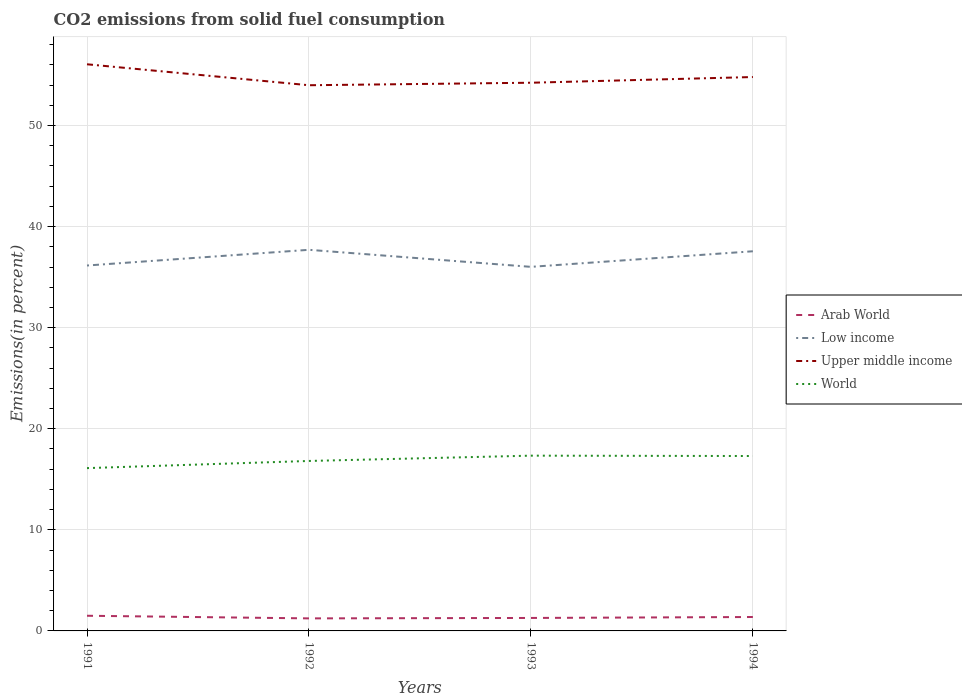Is the number of lines equal to the number of legend labels?
Offer a very short reply. Yes. Across all years, what is the maximum total CO2 emitted in Upper middle income?
Ensure brevity in your answer.  53.99. What is the total total CO2 emitted in Low income in the graph?
Your response must be concise. -1.55. What is the difference between the highest and the second highest total CO2 emitted in Upper middle income?
Your response must be concise. 2.07. What is the difference between two consecutive major ticks on the Y-axis?
Offer a very short reply. 10. Does the graph contain any zero values?
Your answer should be compact. No. Does the graph contain grids?
Make the answer very short. Yes. How many legend labels are there?
Ensure brevity in your answer.  4. How are the legend labels stacked?
Keep it short and to the point. Vertical. What is the title of the graph?
Keep it short and to the point. CO2 emissions from solid fuel consumption. What is the label or title of the X-axis?
Give a very brief answer. Years. What is the label or title of the Y-axis?
Provide a short and direct response. Emissions(in percent). What is the Emissions(in percent) of Arab World in 1991?
Your response must be concise. 1.5. What is the Emissions(in percent) in Low income in 1991?
Offer a terse response. 36.15. What is the Emissions(in percent) in Upper middle income in 1991?
Ensure brevity in your answer.  56.06. What is the Emissions(in percent) in World in 1991?
Your answer should be compact. 16.11. What is the Emissions(in percent) of Arab World in 1992?
Provide a succinct answer. 1.24. What is the Emissions(in percent) in Low income in 1992?
Your answer should be compact. 37.7. What is the Emissions(in percent) of Upper middle income in 1992?
Offer a terse response. 53.99. What is the Emissions(in percent) of World in 1992?
Your response must be concise. 16.81. What is the Emissions(in percent) in Arab World in 1993?
Ensure brevity in your answer.  1.28. What is the Emissions(in percent) in Low income in 1993?
Your answer should be very brief. 36.02. What is the Emissions(in percent) of Upper middle income in 1993?
Provide a succinct answer. 54.23. What is the Emissions(in percent) in World in 1993?
Ensure brevity in your answer.  17.34. What is the Emissions(in percent) in Arab World in 1994?
Ensure brevity in your answer.  1.38. What is the Emissions(in percent) of Low income in 1994?
Make the answer very short. 37.56. What is the Emissions(in percent) in Upper middle income in 1994?
Your response must be concise. 54.8. What is the Emissions(in percent) of World in 1994?
Your answer should be compact. 17.3. Across all years, what is the maximum Emissions(in percent) of Arab World?
Ensure brevity in your answer.  1.5. Across all years, what is the maximum Emissions(in percent) in Low income?
Offer a terse response. 37.7. Across all years, what is the maximum Emissions(in percent) of Upper middle income?
Your answer should be compact. 56.06. Across all years, what is the maximum Emissions(in percent) of World?
Keep it short and to the point. 17.34. Across all years, what is the minimum Emissions(in percent) of Arab World?
Your answer should be compact. 1.24. Across all years, what is the minimum Emissions(in percent) of Low income?
Ensure brevity in your answer.  36.02. Across all years, what is the minimum Emissions(in percent) in Upper middle income?
Ensure brevity in your answer.  53.99. Across all years, what is the minimum Emissions(in percent) in World?
Keep it short and to the point. 16.11. What is the total Emissions(in percent) of Arab World in the graph?
Your answer should be compact. 5.4. What is the total Emissions(in percent) in Low income in the graph?
Offer a very short reply. 147.43. What is the total Emissions(in percent) of Upper middle income in the graph?
Give a very brief answer. 219.07. What is the total Emissions(in percent) in World in the graph?
Your answer should be very brief. 67.56. What is the difference between the Emissions(in percent) in Arab World in 1991 and that in 1992?
Offer a terse response. 0.26. What is the difference between the Emissions(in percent) of Low income in 1991 and that in 1992?
Provide a succinct answer. -1.55. What is the difference between the Emissions(in percent) in Upper middle income in 1991 and that in 1992?
Make the answer very short. 2.07. What is the difference between the Emissions(in percent) of World in 1991 and that in 1992?
Offer a very short reply. -0.71. What is the difference between the Emissions(in percent) of Arab World in 1991 and that in 1993?
Keep it short and to the point. 0.22. What is the difference between the Emissions(in percent) of Low income in 1991 and that in 1993?
Make the answer very short. 0.13. What is the difference between the Emissions(in percent) of Upper middle income in 1991 and that in 1993?
Your answer should be compact. 1.83. What is the difference between the Emissions(in percent) in World in 1991 and that in 1993?
Offer a terse response. -1.23. What is the difference between the Emissions(in percent) in Arab World in 1991 and that in 1994?
Provide a succinct answer. 0.12. What is the difference between the Emissions(in percent) in Low income in 1991 and that in 1994?
Offer a terse response. -1.41. What is the difference between the Emissions(in percent) of Upper middle income in 1991 and that in 1994?
Offer a terse response. 1.26. What is the difference between the Emissions(in percent) in World in 1991 and that in 1994?
Provide a short and direct response. -1.2. What is the difference between the Emissions(in percent) in Arab World in 1992 and that in 1993?
Provide a short and direct response. -0.04. What is the difference between the Emissions(in percent) of Low income in 1992 and that in 1993?
Provide a succinct answer. 1.69. What is the difference between the Emissions(in percent) of Upper middle income in 1992 and that in 1993?
Provide a short and direct response. -0.25. What is the difference between the Emissions(in percent) in World in 1992 and that in 1993?
Offer a terse response. -0.52. What is the difference between the Emissions(in percent) of Arab World in 1992 and that in 1994?
Provide a succinct answer. -0.14. What is the difference between the Emissions(in percent) of Low income in 1992 and that in 1994?
Provide a short and direct response. 0.14. What is the difference between the Emissions(in percent) in Upper middle income in 1992 and that in 1994?
Provide a short and direct response. -0.81. What is the difference between the Emissions(in percent) in World in 1992 and that in 1994?
Your answer should be very brief. -0.49. What is the difference between the Emissions(in percent) in Arab World in 1993 and that in 1994?
Offer a terse response. -0.09. What is the difference between the Emissions(in percent) in Low income in 1993 and that in 1994?
Give a very brief answer. -1.54. What is the difference between the Emissions(in percent) in Upper middle income in 1993 and that in 1994?
Offer a terse response. -0.56. What is the difference between the Emissions(in percent) of World in 1993 and that in 1994?
Your answer should be very brief. 0.04. What is the difference between the Emissions(in percent) in Arab World in 1991 and the Emissions(in percent) in Low income in 1992?
Provide a short and direct response. -36.2. What is the difference between the Emissions(in percent) of Arab World in 1991 and the Emissions(in percent) of Upper middle income in 1992?
Your answer should be very brief. -52.48. What is the difference between the Emissions(in percent) in Arab World in 1991 and the Emissions(in percent) in World in 1992?
Offer a terse response. -15.31. What is the difference between the Emissions(in percent) in Low income in 1991 and the Emissions(in percent) in Upper middle income in 1992?
Your response must be concise. -17.83. What is the difference between the Emissions(in percent) in Low income in 1991 and the Emissions(in percent) in World in 1992?
Offer a terse response. 19.34. What is the difference between the Emissions(in percent) in Upper middle income in 1991 and the Emissions(in percent) in World in 1992?
Make the answer very short. 39.24. What is the difference between the Emissions(in percent) of Arab World in 1991 and the Emissions(in percent) of Low income in 1993?
Your answer should be compact. -34.52. What is the difference between the Emissions(in percent) in Arab World in 1991 and the Emissions(in percent) in Upper middle income in 1993?
Give a very brief answer. -52.73. What is the difference between the Emissions(in percent) in Arab World in 1991 and the Emissions(in percent) in World in 1993?
Keep it short and to the point. -15.84. What is the difference between the Emissions(in percent) of Low income in 1991 and the Emissions(in percent) of Upper middle income in 1993?
Your answer should be compact. -18.08. What is the difference between the Emissions(in percent) in Low income in 1991 and the Emissions(in percent) in World in 1993?
Your answer should be compact. 18.81. What is the difference between the Emissions(in percent) of Upper middle income in 1991 and the Emissions(in percent) of World in 1993?
Your answer should be compact. 38.72. What is the difference between the Emissions(in percent) in Arab World in 1991 and the Emissions(in percent) in Low income in 1994?
Ensure brevity in your answer.  -36.06. What is the difference between the Emissions(in percent) in Arab World in 1991 and the Emissions(in percent) in Upper middle income in 1994?
Your answer should be very brief. -53.3. What is the difference between the Emissions(in percent) in Arab World in 1991 and the Emissions(in percent) in World in 1994?
Make the answer very short. -15.8. What is the difference between the Emissions(in percent) in Low income in 1991 and the Emissions(in percent) in Upper middle income in 1994?
Provide a succinct answer. -18.65. What is the difference between the Emissions(in percent) in Low income in 1991 and the Emissions(in percent) in World in 1994?
Your response must be concise. 18.85. What is the difference between the Emissions(in percent) in Upper middle income in 1991 and the Emissions(in percent) in World in 1994?
Your answer should be very brief. 38.75. What is the difference between the Emissions(in percent) in Arab World in 1992 and the Emissions(in percent) in Low income in 1993?
Keep it short and to the point. -34.78. What is the difference between the Emissions(in percent) of Arab World in 1992 and the Emissions(in percent) of Upper middle income in 1993?
Keep it short and to the point. -52.99. What is the difference between the Emissions(in percent) in Arab World in 1992 and the Emissions(in percent) in World in 1993?
Give a very brief answer. -16.1. What is the difference between the Emissions(in percent) in Low income in 1992 and the Emissions(in percent) in Upper middle income in 1993?
Offer a very short reply. -16.53. What is the difference between the Emissions(in percent) in Low income in 1992 and the Emissions(in percent) in World in 1993?
Provide a succinct answer. 20.36. What is the difference between the Emissions(in percent) in Upper middle income in 1992 and the Emissions(in percent) in World in 1993?
Offer a terse response. 36.65. What is the difference between the Emissions(in percent) in Arab World in 1992 and the Emissions(in percent) in Low income in 1994?
Provide a short and direct response. -36.32. What is the difference between the Emissions(in percent) in Arab World in 1992 and the Emissions(in percent) in Upper middle income in 1994?
Provide a succinct answer. -53.56. What is the difference between the Emissions(in percent) of Arab World in 1992 and the Emissions(in percent) of World in 1994?
Give a very brief answer. -16.06. What is the difference between the Emissions(in percent) of Low income in 1992 and the Emissions(in percent) of Upper middle income in 1994?
Keep it short and to the point. -17.09. What is the difference between the Emissions(in percent) in Low income in 1992 and the Emissions(in percent) in World in 1994?
Provide a succinct answer. 20.4. What is the difference between the Emissions(in percent) of Upper middle income in 1992 and the Emissions(in percent) of World in 1994?
Offer a terse response. 36.68. What is the difference between the Emissions(in percent) of Arab World in 1993 and the Emissions(in percent) of Low income in 1994?
Your answer should be very brief. -36.28. What is the difference between the Emissions(in percent) of Arab World in 1993 and the Emissions(in percent) of Upper middle income in 1994?
Your response must be concise. -53.51. What is the difference between the Emissions(in percent) in Arab World in 1993 and the Emissions(in percent) in World in 1994?
Keep it short and to the point. -16.02. What is the difference between the Emissions(in percent) of Low income in 1993 and the Emissions(in percent) of Upper middle income in 1994?
Offer a terse response. -18.78. What is the difference between the Emissions(in percent) of Low income in 1993 and the Emissions(in percent) of World in 1994?
Your answer should be compact. 18.71. What is the difference between the Emissions(in percent) in Upper middle income in 1993 and the Emissions(in percent) in World in 1994?
Provide a succinct answer. 36.93. What is the average Emissions(in percent) of Arab World per year?
Your answer should be very brief. 1.35. What is the average Emissions(in percent) in Low income per year?
Your response must be concise. 36.86. What is the average Emissions(in percent) of Upper middle income per year?
Provide a short and direct response. 54.77. What is the average Emissions(in percent) in World per year?
Keep it short and to the point. 16.89. In the year 1991, what is the difference between the Emissions(in percent) of Arab World and Emissions(in percent) of Low income?
Your answer should be very brief. -34.65. In the year 1991, what is the difference between the Emissions(in percent) of Arab World and Emissions(in percent) of Upper middle income?
Keep it short and to the point. -54.56. In the year 1991, what is the difference between the Emissions(in percent) of Arab World and Emissions(in percent) of World?
Offer a terse response. -14.61. In the year 1991, what is the difference between the Emissions(in percent) in Low income and Emissions(in percent) in Upper middle income?
Give a very brief answer. -19.91. In the year 1991, what is the difference between the Emissions(in percent) in Low income and Emissions(in percent) in World?
Give a very brief answer. 20.04. In the year 1991, what is the difference between the Emissions(in percent) in Upper middle income and Emissions(in percent) in World?
Offer a terse response. 39.95. In the year 1992, what is the difference between the Emissions(in percent) of Arab World and Emissions(in percent) of Low income?
Keep it short and to the point. -36.46. In the year 1992, what is the difference between the Emissions(in percent) of Arab World and Emissions(in percent) of Upper middle income?
Provide a short and direct response. -52.74. In the year 1992, what is the difference between the Emissions(in percent) in Arab World and Emissions(in percent) in World?
Provide a short and direct response. -15.57. In the year 1992, what is the difference between the Emissions(in percent) of Low income and Emissions(in percent) of Upper middle income?
Give a very brief answer. -16.28. In the year 1992, what is the difference between the Emissions(in percent) in Low income and Emissions(in percent) in World?
Offer a terse response. 20.89. In the year 1992, what is the difference between the Emissions(in percent) in Upper middle income and Emissions(in percent) in World?
Ensure brevity in your answer.  37.17. In the year 1993, what is the difference between the Emissions(in percent) in Arab World and Emissions(in percent) in Low income?
Your answer should be compact. -34.73. In the year 1993, what is the difference between the Emissions(in percent) in Arab World and Emissions(in percent) in Upper middle income?
Offer a terse response. -52.95. In the year 1993, what is the difference between the Emissions(in percent) of Arab World and Emissions(in percent) of World?
Keep it short and to the point. -16.06. In the year 1993, what is the difference between the Emissions(in percent) of Low income and Emissions(in percent) of Upper middle income?
Ensure brevity in your answer.  -18.22. In the year 1993, what is the difference between the Emissions(in percent) in Low income and Emissions(in percent) in World?
Your answer should be compact. 18.68. In the year 1993, what is the difference between the Emissions(in percent) in Upper middle income and Emissions(in percent) in World?
Your answer should be compact. 36.89. In the year 1994, what is the difference between the Emissions(in percent) in Arab World and Emissions(in percent) in Low income?
Your response must be concise. -36.18. In the year 1994, what is the difference between the Emissions(in percent) of Arab World and Emissions(in percent) of Upper middle income?
Offer a very short reply. -53.42. In the year 1994, what is the difference between the Emissions(in percent) in Arab World and Emissions(in percent) in World?
Your answer should be compact. -15.93. In the year 1994, what is the difference between the Emissions(in percent) of Low income and Emissions(in percent) of Upper middle income?
Ensure brevity in your answer.  -17.24. In the year 1994, what is the difference between the Emissions(in percent) in Low income and Emissions(in percent) in World?
Offer a terse response. 20.26. In the year 1994, what is the difference between the Emissions(in percent) of Upper middle income and Emissions(in percent) of World?
Ensure brevity in your answer.  37.49. What is the ratio of the Emissions(in percent) of Arab World in 1991 to that in 1992?
Your answer should be very brief. 1.21. What is the ratio of the Emissions(in percent) of Low income in 1991 to that in 1992?
Keep it short and to the point. 0.96. What is the ratio of the Emissions(in percent) of Upper middle income in 1991 to that in 1992?
Offer a terse response. 1.04. What is the ratio of the Emissions(in percent) of World in 1991 to that in 1992?
Keep it short and to the point. 0.96. What is the ratio of the Emissions(in percent) of Arab World in 1991 to that in 1993?
Provide a short and direct response. 1.17. What is the ratio of the Emissions(in percent) of Low income in 1991 to that in 1993?
Give a very brief answer. 1. What is the ratio of the Emissions(in percent) in Upper middle income in 1991 to that in 1993?
Give a very brief answer. 1.03. What is the ratio of the Emissions(in percent) in World in 1991 to that in 1993?
Make the answer very short. 0.93. What is the ratio of the Emissions(in percent) of Arab World in 1991 to that in 1994?
Your answer should be very brief. 1.09. What is the ratio of the Emissions(in percent) in Low income in 1991 to that in 1994?
Your answer should be compact. 0.96. What is the ratio of the Emissions(in percent) of World in 1991 to that in 1994?
Make the answer very short. 0.93. What is the ratio of the Emissions(in percent) in Arab World in 1992 to that in 1993?
Offer a very short reply. 0.97. What is the ratio of the Emissions(in percent) of Low income in 1992 to that in 1993?
Provide a succinct answer. 1.05. What is the ratio of the Emissions(in percent) in World in 1992 to that in 1993?
Your response must be concise. 0.97. What is the ratio of the Emissions(in percent) in Arab World in 1992 to that in 1994?
Your answer should be very brief. 0.9. What is the ratio of the Emissions(in percent) in Upper middle income in 1992 to that in 1994?
Offer a very short reply. 0.99. What is the ratio of the Emissions(in percent) in World in 1992 to that in 1994?
Offer a terse response. 0.97. What is the ratio of the Emissions(in percent) of Arab World in 1993 to that in 1994?
Provide a succinct answer. 0.93. What is the ratio of the Emissions(in percent) of World in 1993 to that in 1994?
Your answer should be very brief. 1. What is the difference between the highest and the second highest Emissions(in percent) in Arab World?
Your response must be concise. 0.12. What is the difference between the highest and the second highest Emissions(in percent) in Low income?
Offer a very short reply. 0.14. What is the difference between the highest and the second highest Emissions(in percent) in Upper middle income?
Your response must be concise. 1.26. What is the difference between the highest and the second highest Emissions(in percent) in World?
Ensure brevity in your answer.  0.04. What is the difference between the highest and the lowest Emissions(in percent) in Arab World?
Make the answer very short. 0.26. What is the difference between the highest and the lowest Emissions(in percent) in Low income?
Provide a succinct answer. 1.69. What is the difference between the highest and the lowest Emissions(in percent) of Upper middle income?
Make the answer very short. 2.07. What is the difference between the highest and the lowest Emissions(in percent) of World?
Offer a terse response. 1.23. 